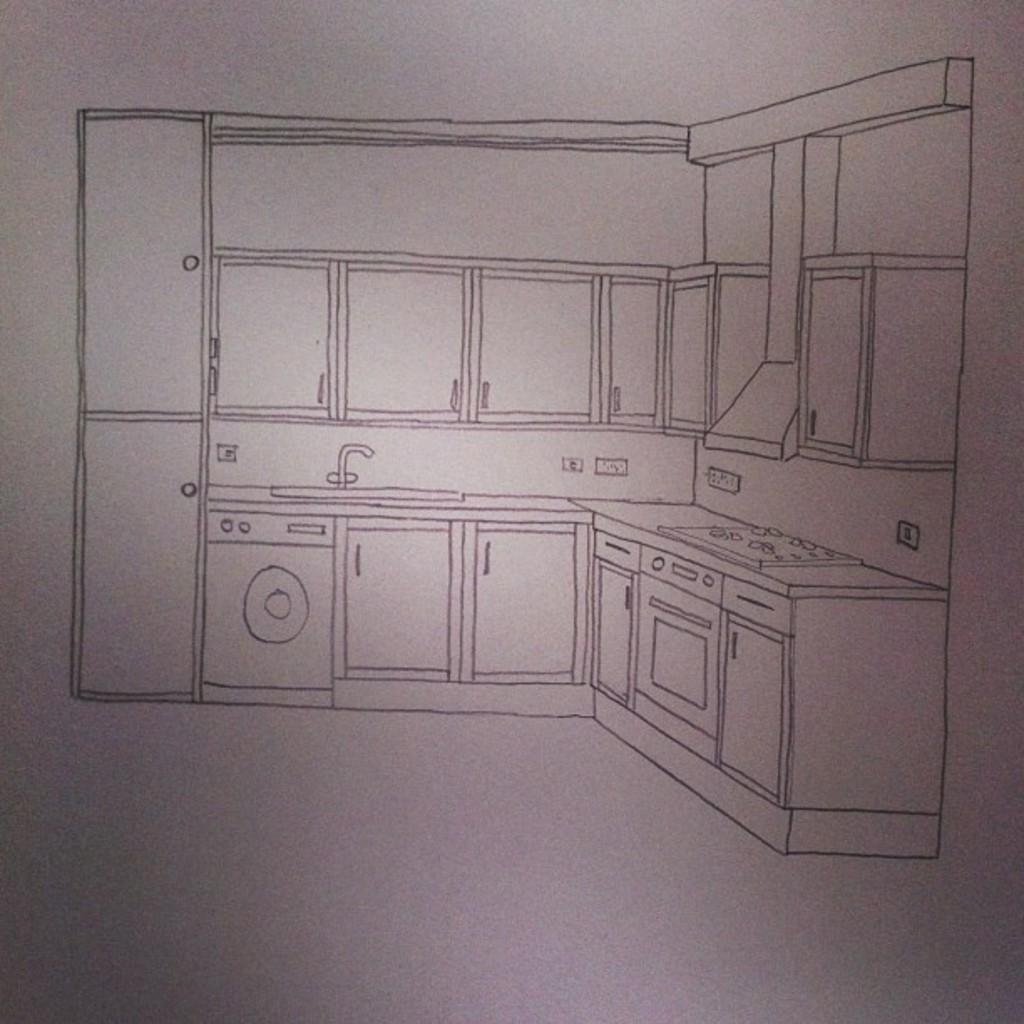What is the main subject of the drawing in the image? The main subject of the drawing in the image is a kitchen. What is the mass of the word "boundary" in the image? There is no word "boundary" present in the image, as it contains a drawing of a kitchen. 